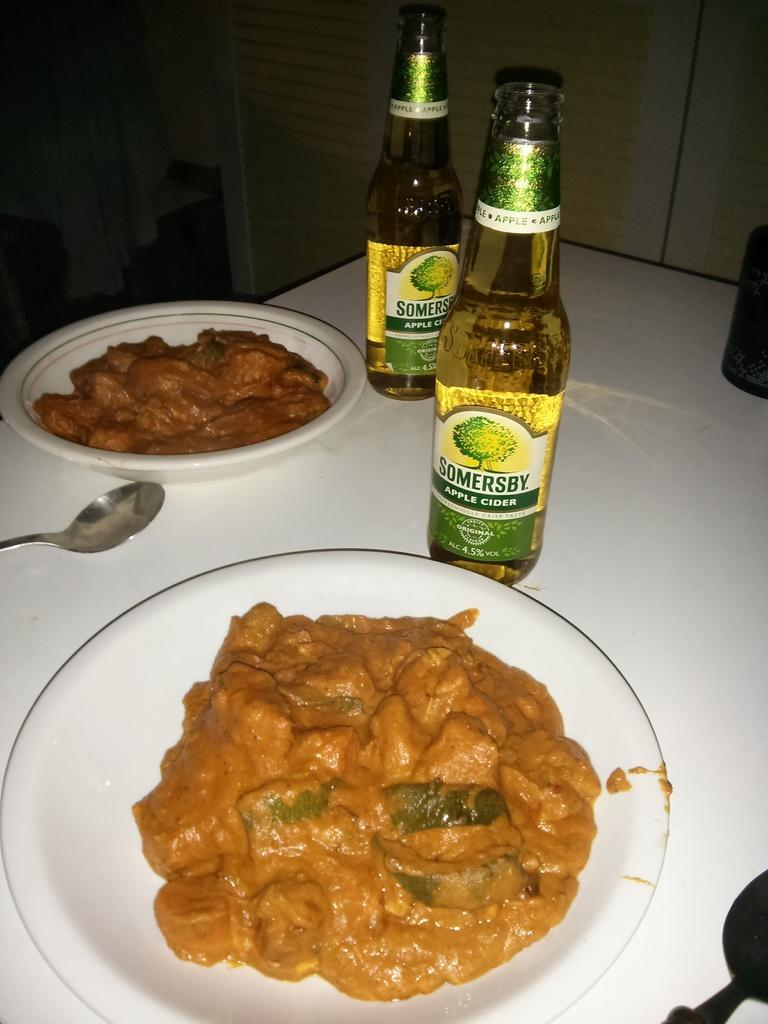<image>
Summarize the visual content of the image. Two plates of food and two bottles of Somersby cider are on a table. 